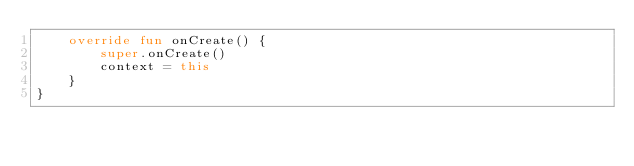<code> <loc_0><loc_0><loc_500><loc_500><_Kotlin_>    override fun onCreate() {
        super.onCreate()
        context = this
    }
}</code> 